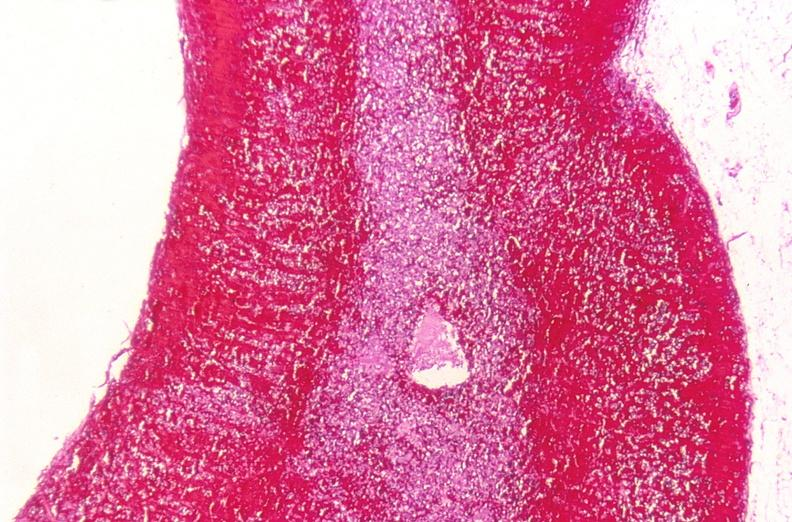s endocrine present?
Answer the question using a single word or phrase. Yes 